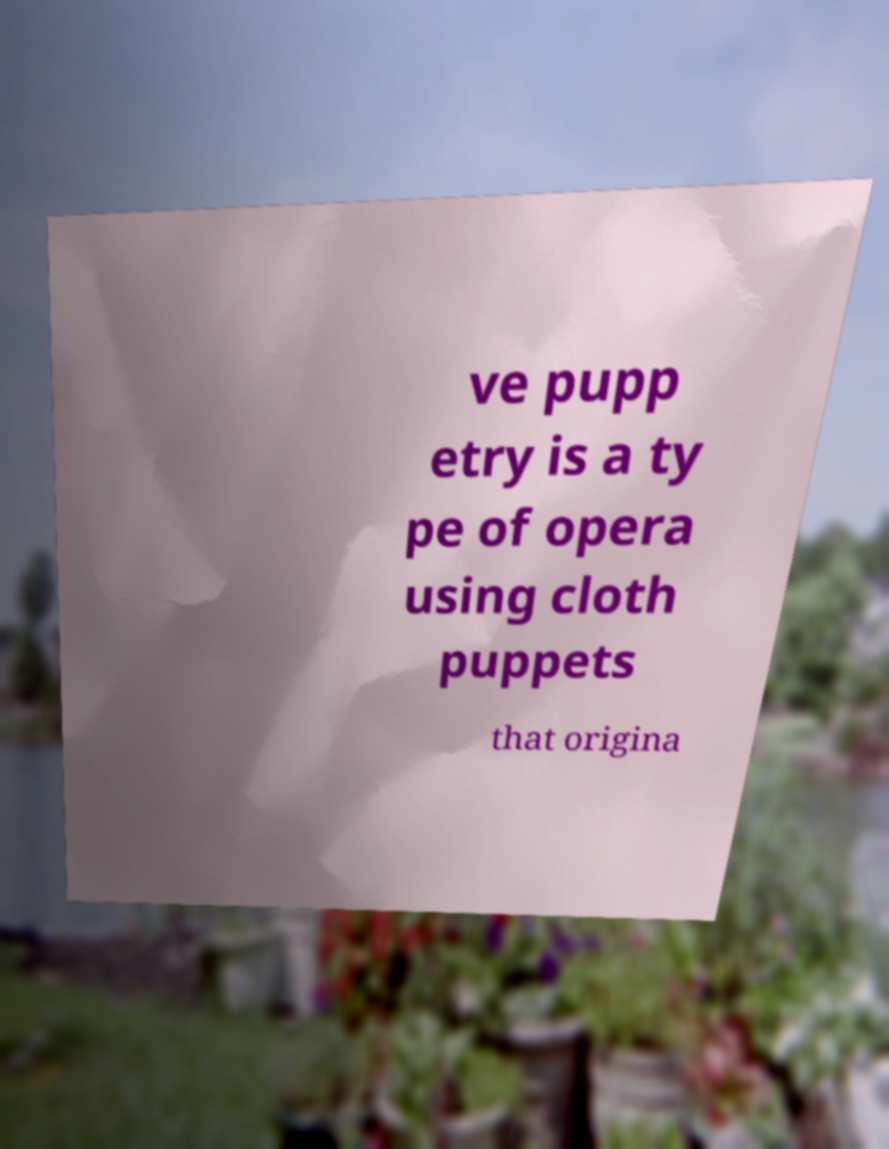There's text embedded in this image that I need extracted. Can you transcribe it verbatim? ve pupp etry is a ty pe of opera using cloth puppets that origina 